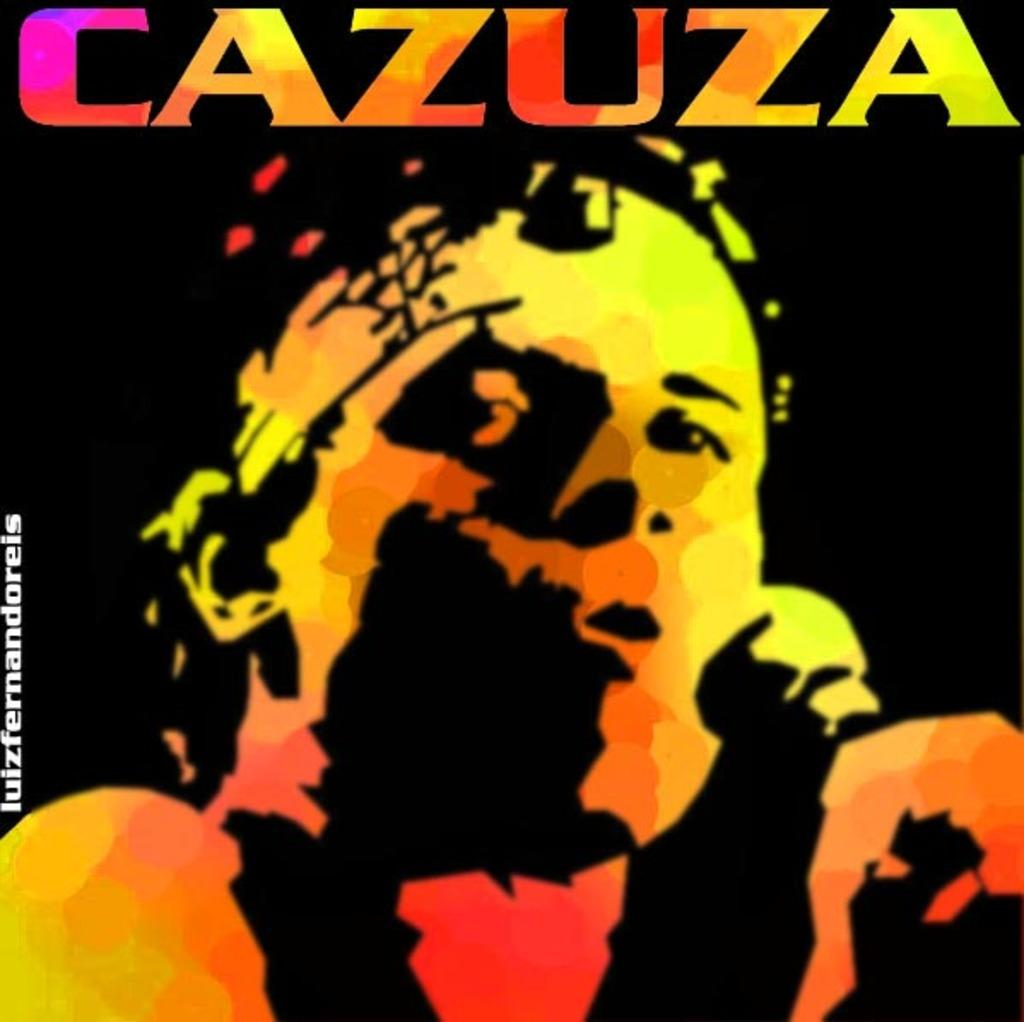<image>
Relay a brief, clear account of the picture shown. A colorful album cover of a band names Cazuza. 